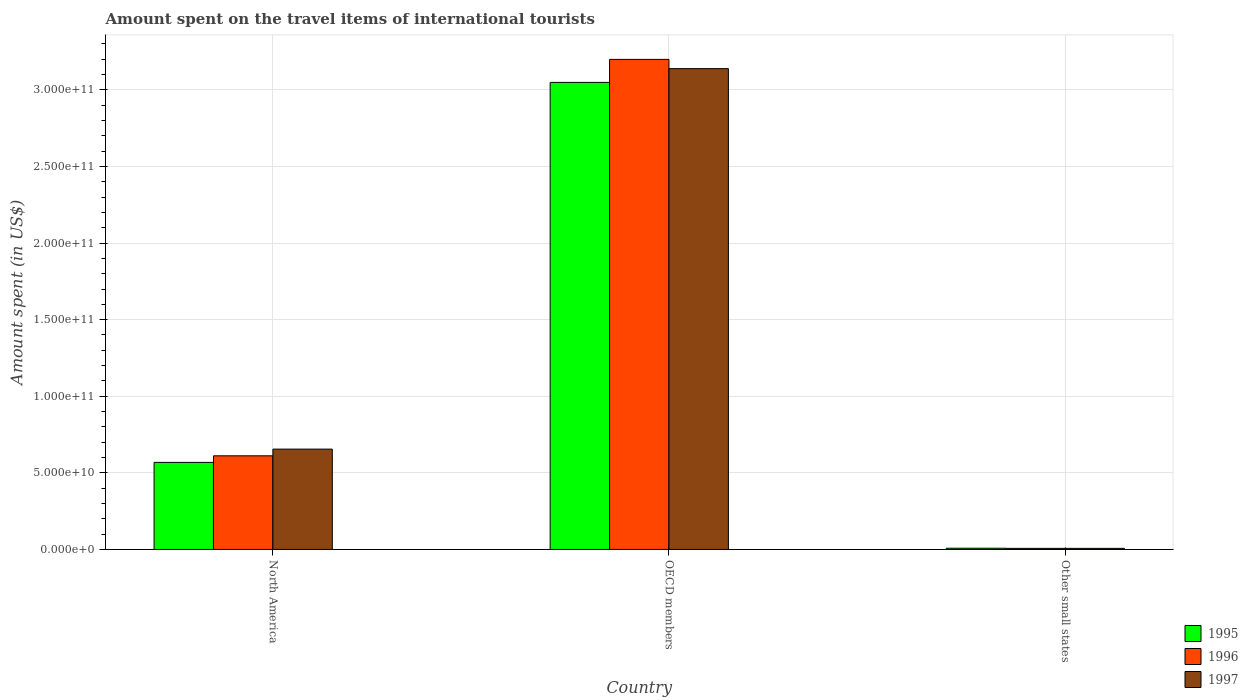How many different coloured bars are there?
Give a very brief answer. 3. How many groups of bars are there?
Keep it short and to the point. 3. What is the amount spent on the travel items of international tourists in 1995 in OECD members?
Offer a terse response. 3.05e+11. Across all countries, what is the maximum amount spent on the travel items of international tourists in 1995?
Give a very brief answer. 3.05e+11. Across all countries, what is the minimum amount spent on the travel items of international tourists in 1996?
Your answer should be very brief. 7.07e+08. In which country was the amount spent on the travel items of international tourists in 1996 maximum?
Provide a short and direct response. OECD members. In which country was the amount spent on the travel items of international tourists in 1997 minimum?
Make the answer very short. Other small states. What is the total amount spent on the travel items of international tourists in 1997 in the graph?
Your answer should be compact. 3.80e+11. What is the difference between the amount spent on the travel items of international tourists in 1997 in North America and that in OECD members?
Keep it short and to the point. -2.48e+11. What is the difference between the amount spent on the travel items of international tourists in 1996 in North America and the amount spent on the travel items of international tourists in 1997 in Other small states?
Give a very brief answer. 6.04e+1. What is the average amount spent on the travel items of international tourists in 1997 per country?
Provide a short and direct response. 1.27e+11. What is the difference between the amount spent on the travel items of international tourists of/in 1996 and amount spent on the travel items of international tourists of/in 1997 in OECD members?
Your answer should be compact. 6.04e+09. What is the ratio of the amount spent on the travel items of international tourists in 1997 in OECD members to that in Other small states?
Make the answer very short. 441.26. Is the difference between the amount spent on the travel items of international tourists in 1996 in North America and Other small states greater than the difference between the amount spent on the travel items of international tourists in 1997 in North America and Other small states?
Provide a short and direct response. No. What is the difference between the highest and the second highest amount spent on the travel items of international tourists in 1997?
Your answer should be compact. 2.48e+11. What is the difference between the highest and the lowest amount spent on the travel items of international tourists in 1997?
Ensure brevity in your answer.  3.13e+11. What does the 3rd bar from the left in North America represents?
Your response must be concise. 1997. Is it the case that in every country, the sum of the amount spent on the travel items of international tourists in 1996 and amount spent on the travel items of international tourists in 1997 is greater than the amount spent on the travel items of international tourists in 1995?
Provide a short and direct response. Yes. Are all the bars in the graph horizontal?
Offer a terse response. No. What is the difference between two consecutive major ticks on the Y-axis?
Provide a succinct answer. 5.00e+1. How many legend labels are there?
Provide a short and direct response. 3. What is the title of the graph?
Give a very brief answer. Amount spent on the travel items of international tourists. What is the label or title of the Y-axis?
Your answer should be very brief. Amount spent (in US$). What is the Amount spent (in US$) of 1995 in North America?
Make the answer very short. 5.68e+1. What is the Amount spent (in US$) in 1996 in North America?
Provide a short and direct response. 6.11e+1. What is the Amount spent (in US$) of 1997 in North America?
Your response must be concise. 6.55e+1. What is the Amount spent (in US$) in 1995 in OECD members?
Make the answer very short. 3.05e+11. What is the Amount spent (in US$) in 1996 in OECD members?
Offer a very short reply. 3.20e+11. What is the Amount spent (in US$) in 1997 in OECD members?
Offer a terse response. 3.14e+11. What is the Amount spent (in US$) in 1995 in Other small states?
Your answer should be very brief. 7.98e+08. What is the Amount spent (in US$) in 1996 in Other small states?
Your response must be concise. 7.07e+08. What is the Amount spent (in US$) of 1997 in Other small states?
Ensure brevity in your answer.  7.11e+08. Across all countries, what is the maximum Amount spent (in US$) in 1995?
Your response must be concise. 3.05e+11. Across all countries, what is the maximum Amount spent (in US$) in 1996?
Ensure brevity in your answer.  3.20e+11. Across all countries, what is the maximum Amount spent (in US$) of 1997?
Your answer should be compact. 3.14e+11. Across all countries, what is the minimum Amount spent (in US$) in 1995?
Give a very brief answer. 7.98e+08. Across all countries, what is the minimum Amount spent (in US$) in 1996?
Provide a short and direct response. 7.07e+08. Across all countries, what is the minimum Amount spent (in US$) in 1997?
Give a very brief answer. 7.11e+08. What is the total Amount spent (in US$) in 1995 in the graph?
Give a very brief answer. 3.62e+11. What is the total Amount spent (in US$) of 1996 in the graph?
Keep it short and to the point. 3.82e+11. What is the total Amount spent (in US$) in 1997 in the graph?
Offer a terse response. 3.80e+11. What is the difference between the Amount spent (in US$) in 1995 in North America and that in OECD members?
Give a very brief answer. -2.48e+11. What is the difference between the Amount spent (in US$) of 1996 in North America and that in OECD members?
Ensure brevity in your answer.  -2.59e+11. What is the difference between the Amount spent (in US$) in 1997 in North America and that in OECD members?
Keep it short and to the point. -2.48e+11. What is the difference between the Amount spent (in US$) of 1995 in North America and that in Other small states?
Your answer should be very brief. 5.60e+1. What is the difference between the Amount spent (in US$) in 1996 in North America and that in Other small states?
Provide a short and direct response. 6.04e+1. What is the difference between the Amount spent (in US$) of 1997 in North America and that in Other small states?
Your answer should be very brief. 6.48e+1. What is the difference between the Amount spent (in US$) of 1995 in OECD members and that in Other small states?
Keep it short and to the point. 3.04e+11. What is the difference between the Amount spent (in US$) of 1996 in OECD members and that in Other small states?
Give a very brief answer. 3.19e+11. What is the difference between the Amount spent (in US$) of 1997 in OECD members and that in Other small states?
Offer a terse response. 3.13e+11. What is the difference between the Amount spent (in US$) of 1995 in North America and the Amount spent (in US$) of 1996 in OECD members?
Your response must be concise. -2.63e+11. What is the difference between the Amount spent (in US$) of 1995 in North America and the Amount spent (in US$) of 1997 in OECD members?
Your response must be concise. -2.57e+11. What is the difference between the Amount spent (in US$) in 1996 in North America and the Amount spent (in US$) in 1997 in OECD members?
Give a very brief answer. -2.53e+11. What is the difference between the Amount spent (in US$) of 1995 in North America and the Amount spent (in US$) of 1996 in Other small states?
Offer a very short reply. 5.61e+1. What is the difference between the Amount spent (in US$) of 1995 in North America and the Amount spent (in US$) of 1997 in Other small states?
Keep it short and to the point. 5.61e+1. What is the difference between the Amount spent (in US$) of 1996 in North America and the Amount spent (in US$) of 1997 in Other small states?
Ensure brevity in your answer.  6.04e+1. What is the difference between the Amount spent (in US$) of 1995 in OECD members and the Amount spent (in US$) of 1996 in Other small states?
Offer a terse response. 3.04e+11. What is the difference between the Amount spent (in US$) in 1995 in OECD members and the Amount spent (in US$) in 1997 in Other small states?
Offer a terse response. 3.04e+11. What is the difference between the Amount spent (in US$) of 1996 in OECD members and the Amount spent (in US$) of 1997 in Other small states?
Offer a very short reply. 3.19e+11. What is the average Amount spent (in US$) in 1995 per country?
Make the answer very short. 1.21e+11. What is the average Amount spent (in US$) in 1996 per country?
Provide a short and direct response. 1.27e+11. What is the average Amount spent (in US$) in 1997 per country?
Make the answer very short. 1.27e+11. What is the difference between the Amount spent (in US$) of 1995 and Amount spent (in US$) of 1996 in North America?
Offer a very short reply. -4.30e+09. What is the difference between the Amount spent (in US$) in 1995 and Amount spent (in US$) in 1997 in North America?
Provide a succinct answer. -8.68e+09. What is the difference between the Amount spent (in US$) in 1996 and Amount spent (in US$) in 1997 in North America?
Your answer should be compact. -4.38e+09. What is the difference between the Amount spent (in US$) of 1995 and Amount spent (in US$) of 1996 in OECD members?
Provide a short and direct response. -1.50e+1. What is the difference between the Amount spent (in US$) in 1995 and Amount spent (in US$) in 1997 in OECD members?
Your answer should be compact. -8.99e+09. What is the difference between the Amount spent (in US$) of 1996 and Amount spent (in US$) of 1997 in OECD members?
Ensure brevity in your answer.  6.04e+09. What is the difference between the Amount spent (in US$) of 1995 and Amount spent (in US$) of 1996 in Other small states?
Offer a terse response. 9.08e+07. What is the difference between the Amount spent (in US$) of 1995 and Amount spent (in US$) of 1997 in Other small states?
Make the answer very short. 8.65e+07. What is the difference between the Amount spent (in US$) of 1996 and Amount spent (in US$) of 1997 in Other small states?
Provide a succinct answer. -4.32e+06. What is the ratio of the Amount spent (in US$) in 1995 in North America to that in OECD members?
Your answer should be very brief. 0.19. What is the ratio of the Amount spent (in US$) of 1996 in North America to that in OECD members?
Make the answer very short. 0.19. What is the ratio of the Amount spent (in US$) of 1997 in North America to that in OECD members?
Your answer should be very brief. 0.21. What is the ratio of the Amount spent (in US$) of 1995 in North America to that in Other small states?
Provide a short and direct response. 71.23. What is the ratio of the Amount spent (in US$) in 1996 in North America to that in Other small states?
Offer a terse response. 86.46. What is the ratio of the Amount spent (in US$) in 1997 in North America to that in Other small states?
Your answer should be very brief. 92.09. What is the ratio of the Amount spent (in US$) of 1995 in OECD members to that in Other small states?
Make the answer very short. 382.16. What is the ratio of the Amount spent (in US$) of 1996 in OECD members to that in Other small states?
Give a very brief answer. 452.5. What is the ratio of the Amount spent (in US$) of 1997 in OECD members to that in Other small states?
Keep it short and to the point. 441.25. What is the difference between the highest and the second highest Amount spent (in US$) in 1995?
Provide a succinct answer. 2.48e+11. What is the difference between the highest and the second highest Amount spent (in US$) of 1996?
Keep it short and to the point. 2.59e+11. What is the difference between the highest and the second highest Amount spent (in US$) in 1997?
Your answer should be compact. 2.48e+11. What is the difference between the highest and the lowest Amount spent (in US$) in 1995?
Provide a succinct answer. 3.04e+11. What is the difference between the highest and the lowest Amount spent (in US$) in 1996?
Provide a short and direct response. 3.19e+11. What is the difference between the highest and the lowest Amount spent (in US$) in 1997?
Ensure brevity in your answer.  3.13e+11. 